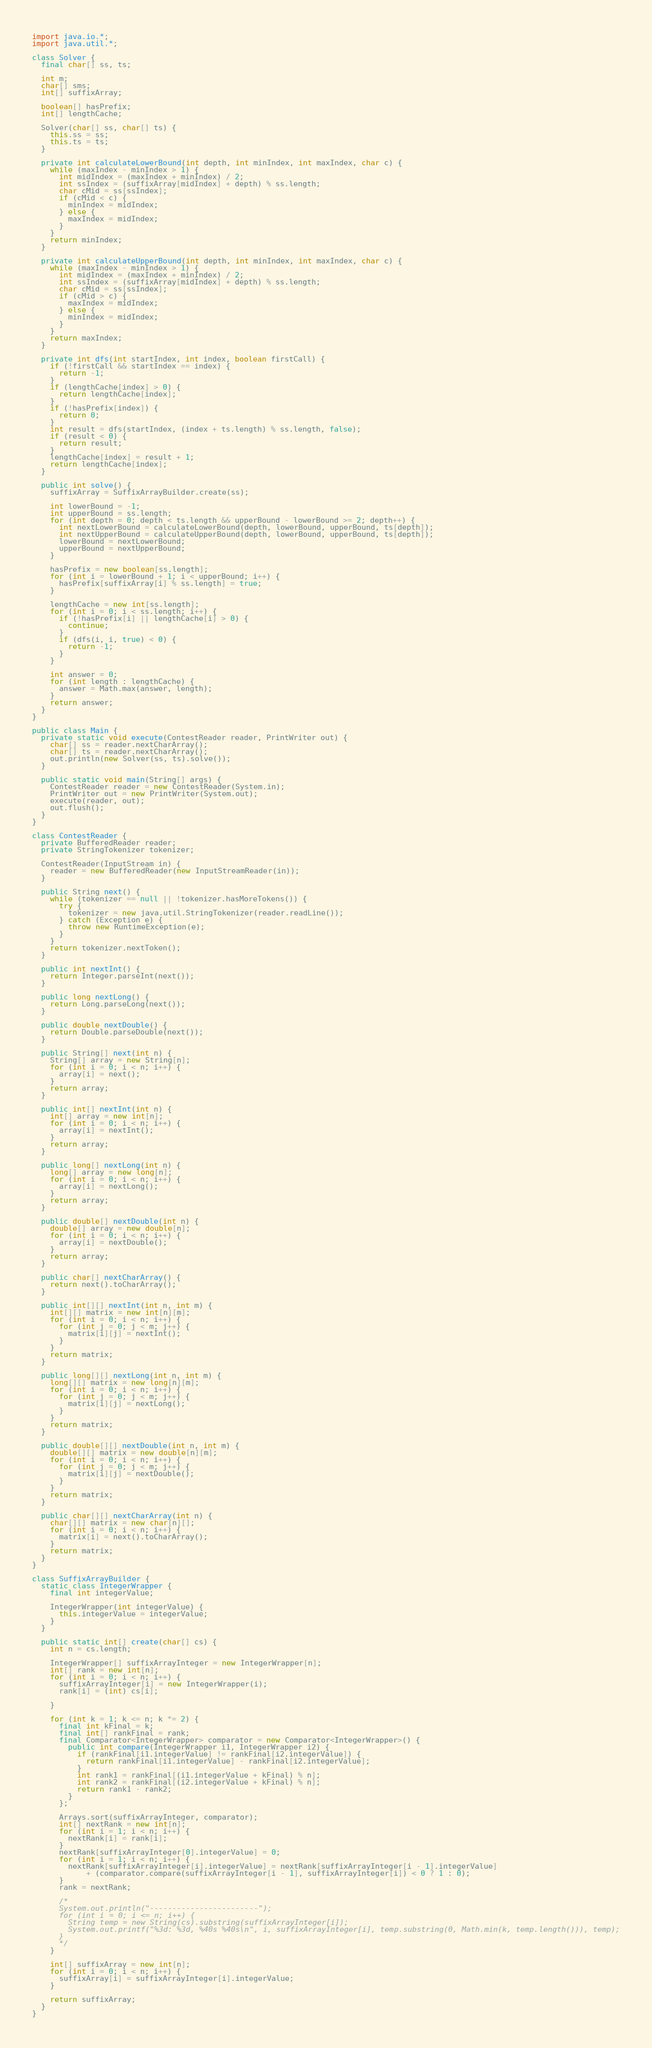<code> <loc_0><loc_0><loc_500><loc_500><_Java_>import java.io.*;
import java.util.*;

class Solver {
  final char[] ss, ts;
  
  int m;
  char[] sms;
  int[] suffixArray;
  
  boolean[] hasPrefix;
  int[] lengthCache;
  
  Solver(char[] ss, char[] ts) {
    this.ss = ss;
    this.ts = ts;
  }
  
  private int calculateLowerBound(int depth, int minIndex, int maxIndex, char c) {
    while (maxIndex - minIndex > 1) {
      int midIndex = (maxIndex + minIndex) / 2;
      int ssIndex = (suffixArray[midIndex] + depth) % ss.length;
      char cMid = ss[ssIndex];
      if (cMid < c) {
        minIndex = midIndex;
      } else {
        maxIndex = midIndex;
      }
    }
    return minIndex;
  }
  
  private int calculateUpperBound(int depth, int minIndex, int maxIndex, char c) {
    while (maxIndex - minIndex > 1) {
      int midIndex = (maxIndex + minIndex) / 2;
      int ssIndex = (suffixArray[midIndex] + depth) % ss.length;
      char cMid = ss[ssIndex];
      if (cMid > c) {
        maxIndex = midIndex;
      } else {
        minIndex = midIndex;
      }
    }
    return maxIndex;
  }
  
  private int dfs(int startIndex, int index, boolean firstCall) {
    if (!firstCall && startIndex == index) {
      return -1;
    }
    if (lengthCache[index] > 0) {
      return lengthCache[index];
    }
    if (!hasPrefix[index]) {
      return 0;
    }
    int result = dfs(startIndex, (index + ts.length) % ss.length, false);
    if (result < 0) {
      return result;
    }
    lengthCache[index] = result + 1;
    return lengthCache[index];
  }
  
  public int solve() {
    suffixArray = SuffixArrayBuilder.create(ss);
    
    int lowerBound = -1;
    int upperBound = ss.length;
    for (int depth = 0; depth < ts.length && upperBound - lowerBound >= 2; depth++) {
      int nextLowerBound = calculateLowerBound(depth, lowerBound, upperBound, ts[depth]);
      int nextUpperBound = calculateUpperBound(depth, lowerBound, upperBound, ts[depth]);
      lowerBound = nextLowerBound;
      upperBound = nextUpperBound;
    }
    
    hasPrefix = new boolean[ss.length];
    for (int i = lowerBound + 1; i < upperBound; i++) {
      hasPrefix[suffixArray[i] % ss.length] = true;
    }
    
    lengthCache = new int[ss.length];
    for (int i = 0; i < ss.length; i++) {
      if (!hasPrefix[i] || lengthCache[i] > 0) {
        continue;
      }
      if (dfs(i, i, true) < 0) {
        return -1;
      }
    }
    
    int answer = 0;
    for (int length : lengthCache) {
      answer = Math.max(answer, length);
    }
    return answer;
  }
}

public class Main {
  private static void execute(ContestReader reader, PrintWriter out) {
    char[] ss = reader.nextCharArray();
    char[] ts = reader.nextCharArray();
    out.println(new Solver(ss, ts).solve());
  }
  
  public static void main(String[] args) {
    ContestReader reader = new ContestReader(System.in);
    PrintWriter out = new PrintWriter(System.out);
    execute(reader, out);
    out.flush();
  }
}

class ContestReader {
  private BufferedReader reader;
  private StringTokenizer tokenizer;
  
  ContestReader(InputStream in) {
    reader = new BufferedReader(new InputStreamReader(in));
  }
  
  public String next() {
    while (tokenizer == null || !tokenizer.hasMoreTokens()) {
      try {
        tokenizer = new java.util.StringTokenizer(reader.readLine());
      } catch (Exception e) {
        throw new RuntimeException(e);
      }
    }
    return tokenizer.nextToken();
  }
  
  public int nextInt() {
    return Integer.parseInt(next());
  }
  
  public long nextLong() {
    return Long.parseLong(next());
  }
  
  public double nextDouble() {
    return Double.parseDouble(next());
  }
  
  public String[] next(int n) {
    String[] array = new String[n];
    for (int i = 0; i < n; i++) {
      array[i] = next();
    }
    return array;
  }
  
  public int[] nextInt(int n) {
    int[] array = new int[n];
    for (int i = 0; i < n; i++) {
      array[i] = nextInt();
    }
    return array;
  }
  
  public long[] nextLong(int n) {
    long[] array = new long[n];
    for (int i = 0; i < n; i++) {
      array[i] = nextLong();
    }
    return array;
  }
  
  public double[] nextDouble(int n) {
    double[] array = new double[n];
    for (int i = 0; i < n; i++) {
      array[i] = nextDouble();
    }
    return array;
  }
  
  public char[] nextCharArray() {
    return next().toCharArray();
  }
  
  public int[][] nextInt(int n, int m) {
    int[][] matrix = new int[n][m];
    for (int i = 0; i < n; i++) {
      for (int j = 0; j < m; j++) {
        matrix[i][j] = nextInt();
      }
    }
    return matrix;
  }
  
  public long[][] nextLong(int n, int m) {
    long[][] matrix = new long[n][m];
    for (int i = 0; i < n; i++) {
      for (int j = 0; j < m; j++) {
        matrix[i][j] = nextLong();
      }
    }
    return matrix;
  }
  
  public double[][] nextDouble(int n, int m) {
    double[][] matrix = new double[n][m];
    for (int i = 0; i < n; i++) {
      for (int j = 0; j < m; j++) {
        matrix[i][j] = nextDouble();
      }
    }
    return matrix;
  }
  
  public char[][] nextCharArray(int n) {
    char[][] matrix = new char[n][];
    for (int i = 0; i < n; i++) {
      matrix[i] = next().toCharArray();
    }
    return matrix;
  }
}

class SuffixArrayBuilder {
  static class IntegerWrapper {
    final int integerValue;
    
    IntegerWrapper(int integerValue) {
      this.integerValue = integerValue;
    }
  }
  
  public static int[] create(char[] cs) {
    int n = cs.length;
    
    IntegerWrapper[] suffixArrayInteger = new IntegerWrapper[n];
    int[] rank = new int[n];
    for (int i = 0; i < n; i++) {
      suffixArrayInteger[i] = new IntegerWrapper(i);
      rank[i] = (int) cs[i];
      
    }
    
    for (int k = 1; k <= n; k *= 2) {
      final int kFinal = k;
      final int[] rankFinal = rank;
      final Comparator<IntegerWrapper> comparator = new Comparator<IntegerWrapper>() {
        public int compare(IntegerWrapper i1, IntegerWrapper i2) {
          if (rankFinal[i1.integerValue] != rankFinal[i2.integerValue]) {
            return rankFinal[i1.integerValue] - rankFinal[i2.integerValue];
          }
          int rank1 = rankFinal[(i1.integerValue + kFinal) % n];
          int rank2 = rankFinal[(i2.integerValue + kFinal) % n];
          return rank1 - rank2;
        }
      };
      
      Arrays.sort(suffixArrayInteger, comparator);
      int[] nextRank = new int[n];
      for (int i = 1; i < n; i++) {
        nextRank[i] = rank[i];
      }
      nextRank[suffixArrayInteger[0].integerValue] = 0;
      for (int i = 1; i < n; i++) {
        nextRank[suffixArrayInteger[i].integerValue] = nextRank[suffixArrayInteger[i - 1].integerValue]
            + (comparator.compare(suffixArrayInteger[i - 1], suffixArrayInteger[i]) < 0 ? 1 : 0);
      }
      rank = nextRank;
      
      /*
      System.out.println("------------------------");
      for (int i = 0; i <= n; i++) {
        String temp = new String(cs).substring(suffixArrayInteger[i]);
        System.out.printf("%3d: %3d, %40s %40s\n", i, suffixArrayInteger[i], temp.substring(0, Math.min(k, temp.length())), temp);
      }
      */
    }
    
    int[] suffixArray = new int[n];
    for (int i = 0; i < n; i++) {
      suffixArray[i] = suffixArrayInteger[i].integerValue;
    }
    
    return suffixArray;
  }
}
</code> 